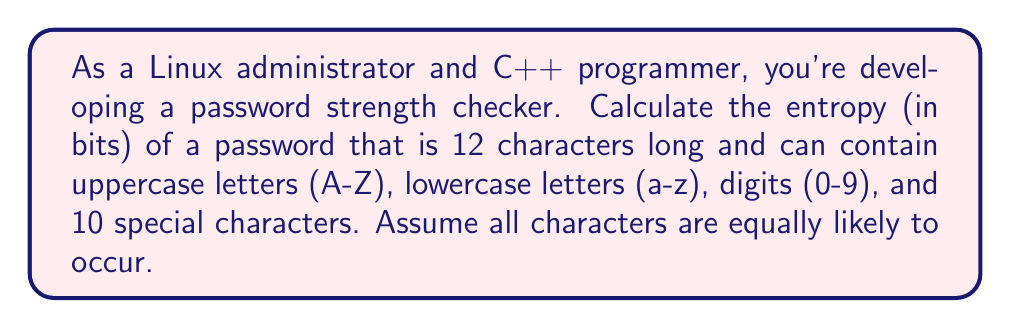What is the answer to this math problem? To calculate the entropy of a password, we need to follow these steps:

1. Determine the size of the character set:
   - Uppercase letters: 26
   - Lowercase letters: 26
   - Digits: 10
   - Special characters: 10
   Total character set size: $26 + 26 + 10 + 10 = 72$

2. Calculate the number of possible passwords:
   With a length of 12 and 72 possible characters for each position, the number of possible passwords is:
   $72^{12}$

3. Calculate the entropy using the formula:
   $\text{Entropy} = \log_2(\text{number of possible passwords})$

   Substituting our values:
   $\text{Entropy} = \log_2(72^{12})$

4. Use the logarithm property $\log_a(x^n) = n \log_a(x)$:
   $\text{Entropy} = 12 \log_2(72)$

5. Calculate the final result:
   $\text{Entropy} = 12 \times 6.169925001442312$
                   $= 74.03910001730774$ bits

Rounding to two decimal places, we get 74.04 bits of entropy.
Answer: 74.04 bits 